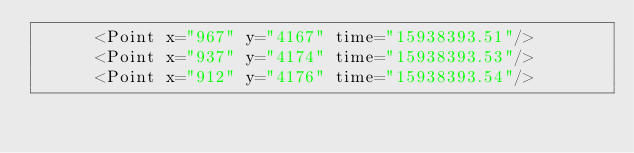<code> <loc_0><loc_0><loc_500><loc_500><_XML_>      <Point x="967" y="4167" time="15938393.51"/>
      <Point x="937" y="4174" time="15938393.53"/>
      <Point x="912" y="4176" time="15938393.54"/></code> 